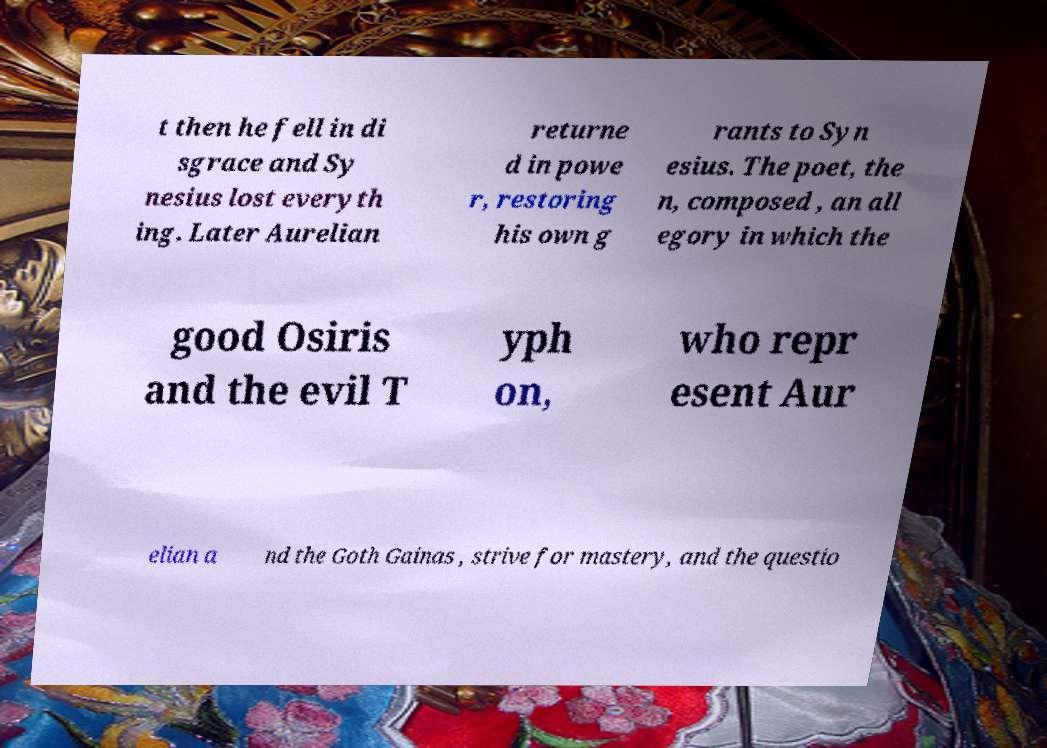Could you assist in decoding the text presented in this image and type it out clearly? t then he fell in di sgrace and Sy nesius lost everyth ing. Later Aurelian returne d in powe r, restoring his own g rants to Syn esius. The poet, the n, composed , an all egory in which the good Osiris and the evil T yph on, who repr esent Aur elian a nd the Goth Gainas , strive for mastery, and the questio 